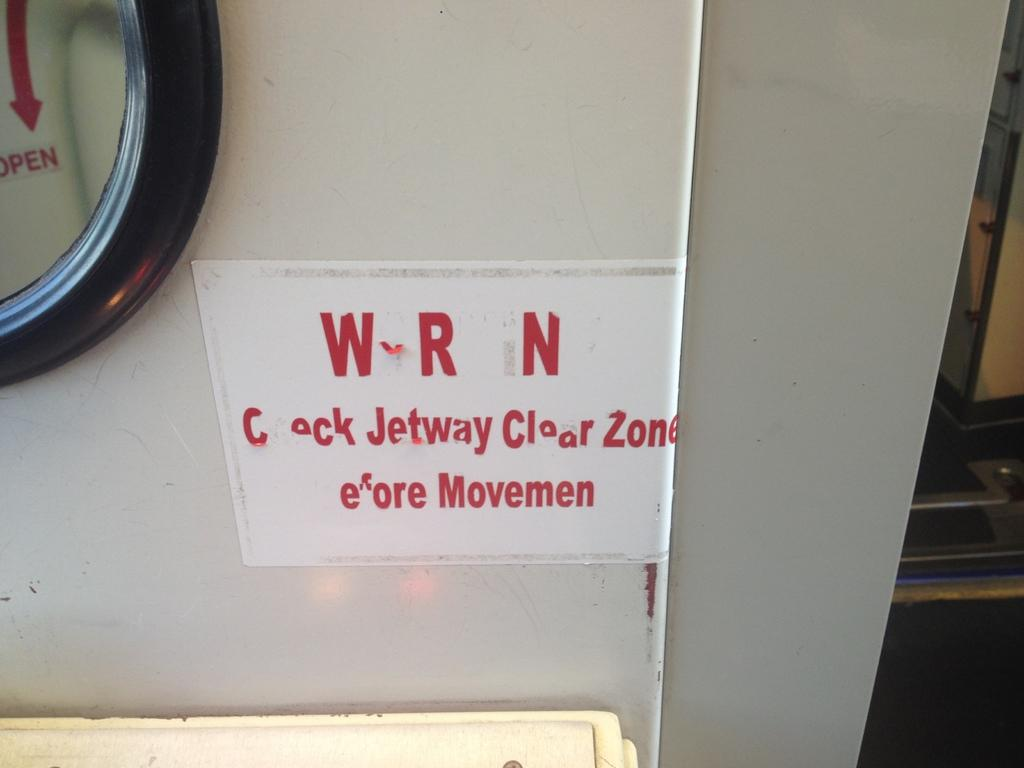What is the main subject in the center of the image? There is a door in the center of the image. What type of test can be seen being conducted on the tray in the image? There is no tray or test present in the image; it only features a door. 